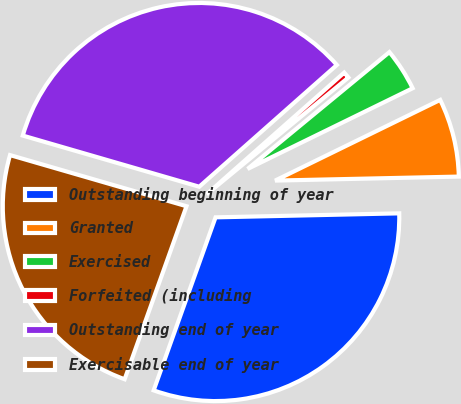Convert chart to OTSL. <chart><loc_0><loc_0><loc_500><loc_500><pie_chart><fcel>Outstanding beginning of year<fcel>Granted<fcel>Exercised<fcel>Forfeited (including<fcel>Outstanding end of year<fcel>Exercisable end of year<nl><fcel>30.81%<fcel>6.89%<fcel>3.73%<fcel>0.56%<fcel>33.98%<fcel>24.02%<nl></chart> 